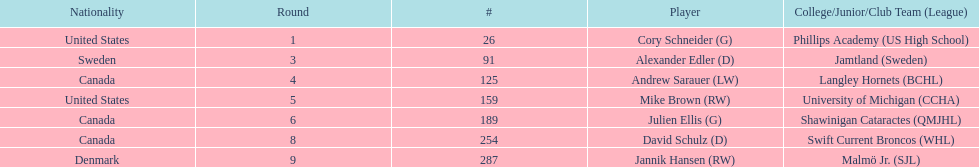How many goalies drafted? 2. 